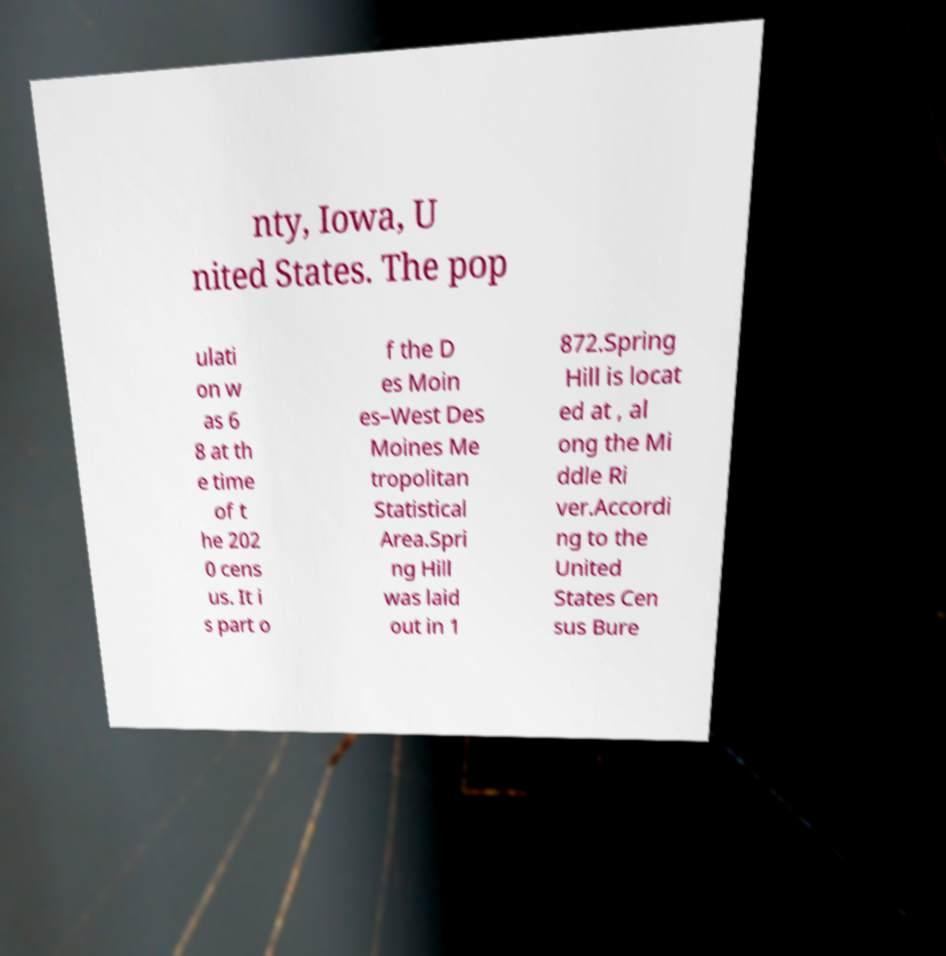I need the written content from this picture converted into text. Can you do that? nty, Iowa, U nited States. The pop ulati on w as 6 8 at th e time of t he 202 0 cens us. It i s part o f the D es Moin es–West Des Moines Me tropolitan Statistical Area.Spri ng Hill was laid out in 1 872.Spring Hill is locat ed at , al ong the Mi ddle Ri ver.Accordi ng to the United States Cen sus Bure 